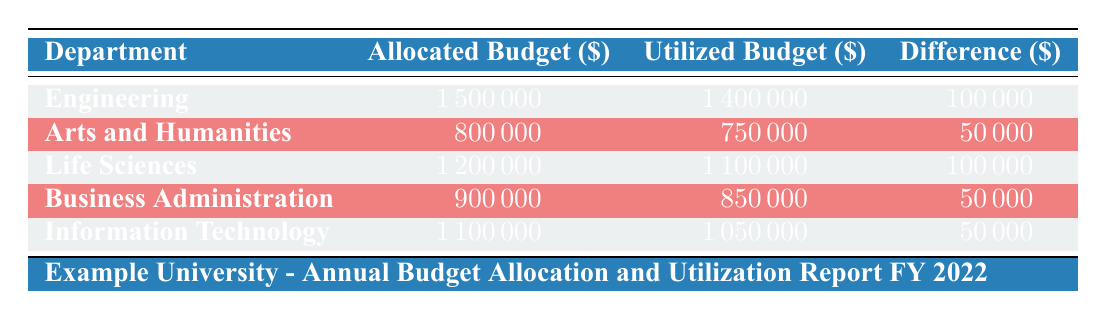What is the total allocated budget for all departments? To find the total allocated budget, sum the allocated budgets of each department: Engineering (1,500,000) + Arts and Humanities (800,000) + Life Sciences (1,200,000) + Business Administration (900,000) + Information Technology (1,100,000) = 5,500,000.
Answer: 5,500,000 Which department has the highest utilized budget? Reviewing the utilized budget for each department: Engineering (1,400,000), Arts and Humanities (750,000), Life Sciences (1,100,000), Business Administration (850,000), Information Technology (1,050,000). Engineering has the highest utilized budget.
Answer: Engineering Is the utilized budget for Arts and Humanities less than the allocated budget? The allocated budget for Arts and Humanities is 800,000 and the utilized budget is 750,000. Since 750,000 is less than 800,000, the statement is true.
Answer: Yes What is the difference between the highest and lowest utilized budgets among the departments? The highest utilized budget is Engineering (1,400,000) and the lowest is Arts and Humanities (750,000). Calculate the difference: 1,400,000 - 750,000 = 650,000.
Answer: 650,000 Does Information Technology have a higher utilized budget than Life Sciences? The utilized budget for Information Technology is 1,050,000, while for Life Sciences it is 1,100,000. Therefore, Information Technology does not have a higher utilized budget.
Answer: No What percentage of the allocated budget was utilized for Business Administration? The utilized budget for Business Administration is 850,000 and the allocated budget is 900,000. To find the percentage utilized: (850,000 / 900,000) * 100 = 94.44%.
Answer: 94.44% Which category in the Engineering department had the lowest utilization? The categories and their utilized amounts in Engineering are: Salaries and Wages (750,000), Research and Development (290,000), Infrastructure (190,000), and Miscellaneous (170,000). Miscellaneous has the lowest utilization at 170,000.
Answer: Miscellaneous If we combine the utilized budgets of Life Sciences and Information Technology, what would that total be? The utilized budget for Life Sciences is 1,100,000 and for Information Technology it is 1,050,000. Adding these together gives: 1,100,000 + 1,050,000 = 2,150,000.
Answer: 2,150,000 